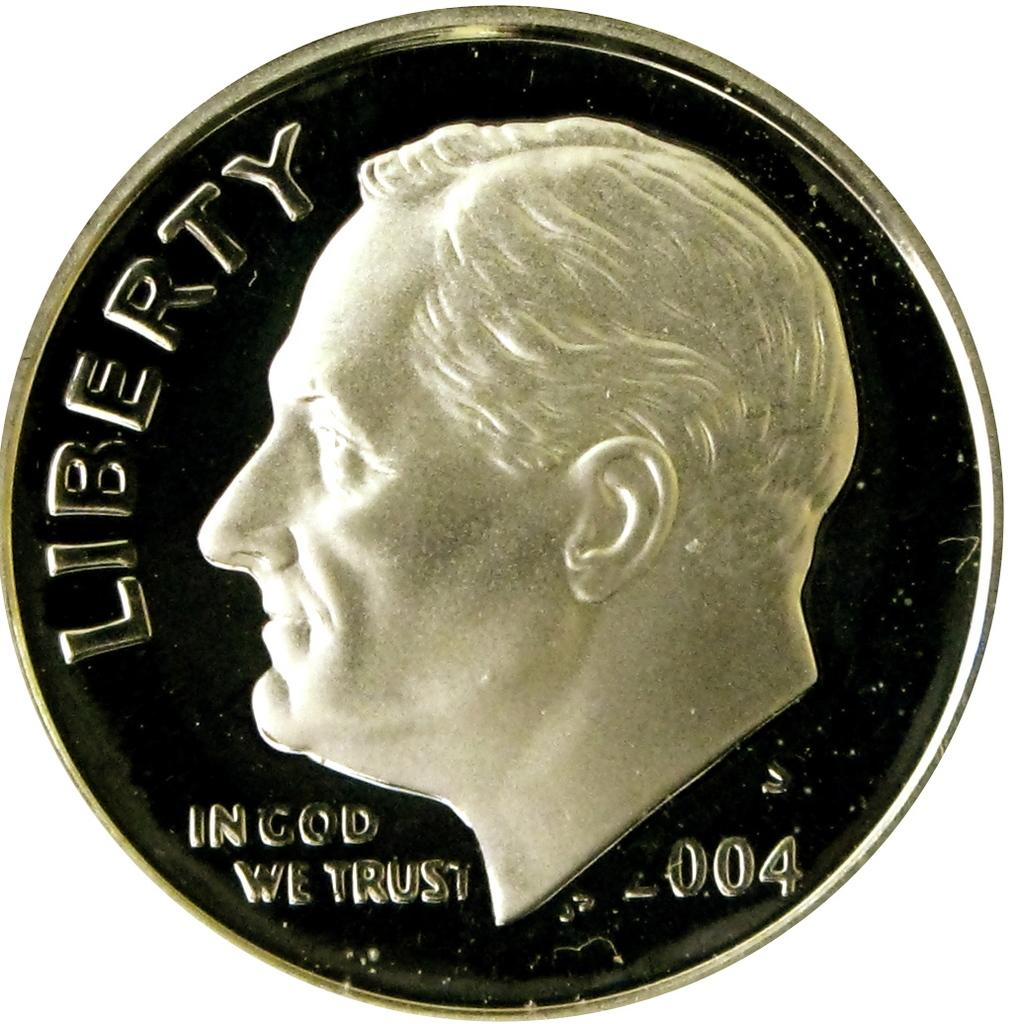<image>
Give a short and clear explanation of the subsequent image. The silver coin shown states that In God We Trust. 